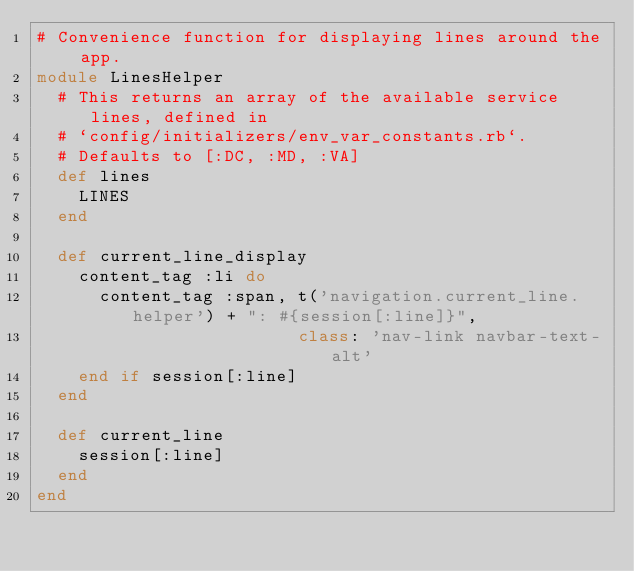Convert code to text. <code><loc_0><loc_0><loc_500><loc_500><_Ruby_># Convenience function for displaying lines around the app.
module LinesHelper
  # This returns an array of the available service lines, defined in
  # `config/initializers/env_var_constants.rb`.
  # Defaults to [:DC, :MD, :VA]
  def lines
    LINES
  end

  def current_line_display
    content_tag :li do
      content_tag :span, t('navigation.current_line.helper') + ": #{session[:line]}",
                         class: 'nav-link navbar-text-alt'
    end if session[:line]
  end

  def current_line
    session[:line]
  end
end
</code> 